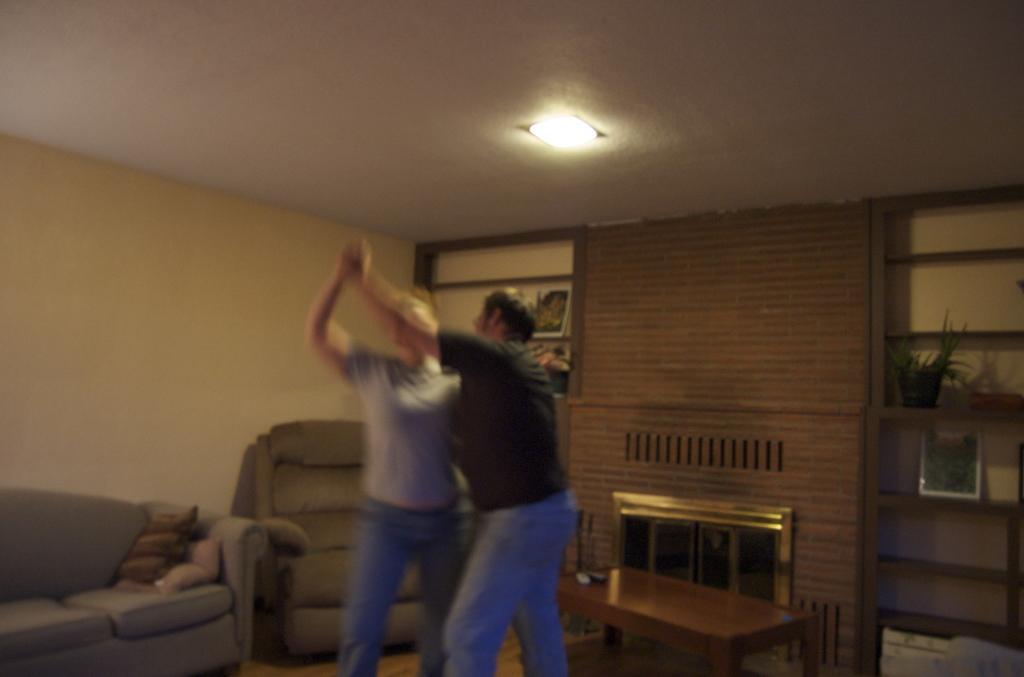Please provide a concise description of this image. this picture shows a inner view of a room a couch and chair two people performing a dance 